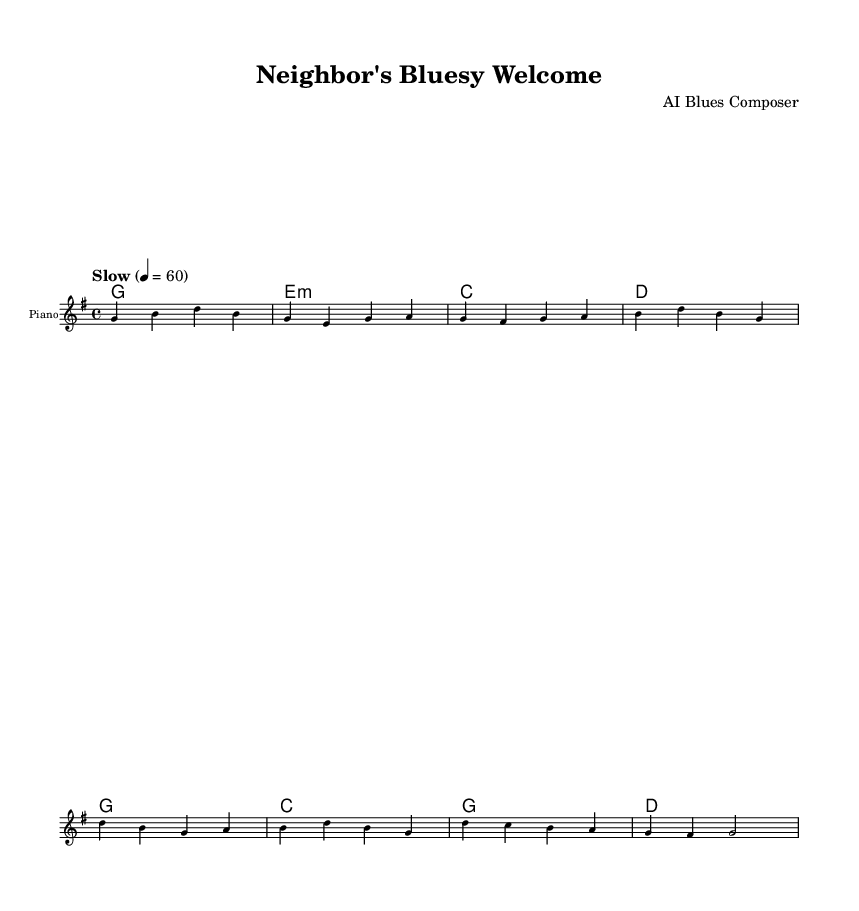What is the key signature of this music? The key signature is G major, which has one sharp, F sharp. This is indicated at the beginning of the sheet music, typically found on the left side where the clef is placed.
Answer: G major What is the time signature of this music? The time signature is 4/4, which means there are four beats in each measure and the quarter note gets one beat. This can be found at the start of the sheet music, usually right after the key signature.
Answer: 4/4 What is the tempo marking for this piece? The tempo marking is "Slow" with a metronome marking of 60 beats per minute. This suggests the piece should be played at a leisurely pace, which can be found written above the staff.
Answer: Slow, 60 How many measures are in the verse? The verse consists of 4 measures. This can be counted by looking at the melody section where each group of notes is contained between vertical bar lines indicating the measures.
Answer: 4 Which chord is played in the first measure of the verse? The chord played in the first measure of the verse is G major, represented by the chord symbol above the melody in the harmonies section. This is the first chord listed in the chord progression for the verse.
Answer: G What is the main theme of the lyrics in the chorus? The main theme of the lyrics is friendship and encouragement. This is evident in lines like "I'm reaching out, with a friendly hand" which emphasize connection and community. This can be derived from the meaning of the lyrics provided.
Answer: Friendship How does the chorus differ from the verse musically? The chorus has a different melodic line and harmonic structure, creating a more uplifting feel compared to the verse. The transition from the verse to the chorus often brings a change in dynamics and rhythm, which can be observed in the change of chord progression and the way the melody notes rise in pitch.
Answer: Different melody and harmony 